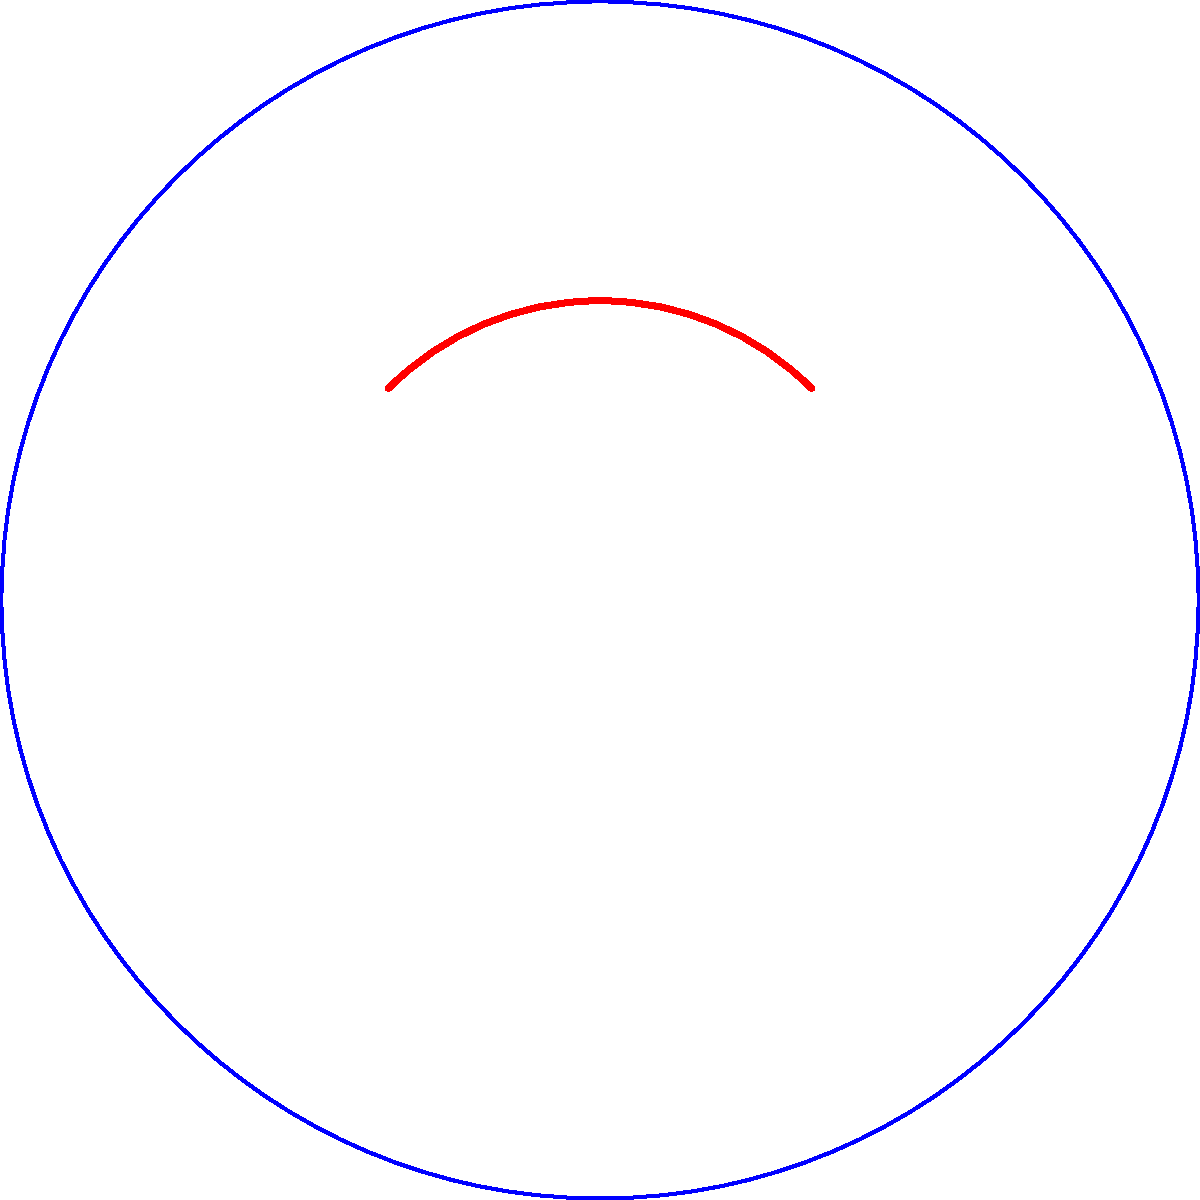As a Ukrainian historian emphasizing geographic accuracy, explain why the area of Ukraine appears different when calculated on a flat map projection compared to its true area on a globe. What is the primary geometric principle that causes this discrepancy? To understand the difference in area calculations between flat maps and globe representations of Ukraine, we need to consider the following steps:

1. Globe representation:
   - The Earth is approximately spherical.
   - Ukraine's surface on a globe follows the curvature of the Earth.
   - The area calculation on a globe uses spherical geometry.

2. Flat map projection:
   - Flat maps are created by projecting the spherical surface onto a plane.
   - This projection inevitably introduces distortions.

3. Geometric principle:
   - The key principle here is the impossibility of preserving both area and shape when projecting a curved surface onto a flat plane.
   - This is a fundamental concept in Non-Euclidean Geometry, specifically in the field of differential geometry.

4. Mathematical explanation:
   - On a sphere with radius $R$, the area of a region is calculated using the formula:
     $$A = R^2 \int\int \sin\phi \,d\phi\,d\theta$$
     where $\phi$ is the latitude and $\theta$ is the longitude.
   - On a flat projection, the area is typically calculated using Euclidean geometry:
     $$A = \int\int dx\,dy$$

5. Mercator projection example:
   - One common projection, the Mercator projection, preserves angles but significantly distorts areas, especially near the poles.
   - The area distortion factor in the Mercator projection is proportional to $\sec^2\phi$, where $\phi$ is the latitude.

6. Impact on Ukraine:
   - Ukraine, located between approximately 44°N and 52°N latitude, experiences noticeable area distortion on many flat map projections.
   - The actual area of Ukraine is about 603,548 km², but this may appear larger or smaller on various flat projections.

The primary geometric principle causing this discrepancy is the fundamental inability to project a curved surface onto a flat plane without distortion, a key concept in Non-Euclidean Geometry.
Answer: Non-Euclidean curvature of Earth's surface 